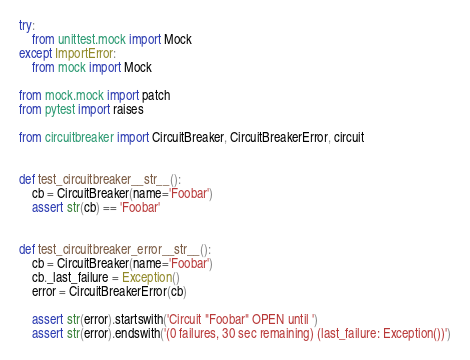Convert code to text. <code><loc_0><loc_0><loc_500><loc_500><_Python_>try:
    from unittest.mock import Mock
except ImportError:
    from mock import Mock

from mock.mock import patch
from pytest import raises

from circuitbreaker import CircuitBreaker, CircuitBreakerError, circuit


def test_circuitbreaker__str__():
    cb = CircuitBreaker(name='Foobar')
    assert str(cb) == 'Foobar'


def test_circuitbreaker_error__str__():
    cb = CircuitBreaker(name='Foobar')
    cb._last_failure = Exception()
    error = CircuitBreakerError(cb)

    assert str(error).startswith('Circuit "Foobar" OPEN until ')
    assert str(error).endswith('(0 failures, 30 sec remaining) (last_failure: Exception())')

</code> 